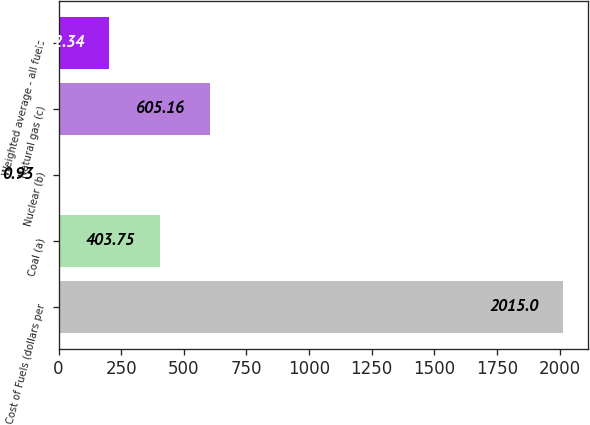Convert chart to OTSL. <chart><loc_0><loc_0><loc_500><loc_500><bar_chart><fcel>Cost of Fuels (dollars per<fcel>Coal (a)<fcel>Nuclear (b)<fcel>Natural gas (c)<fcel>Weighted average - all fuels<nl><fcel>2015<fcel>403.75<fcel>0.93<fcel>605.16<fcel>202.34<nl></chart> 